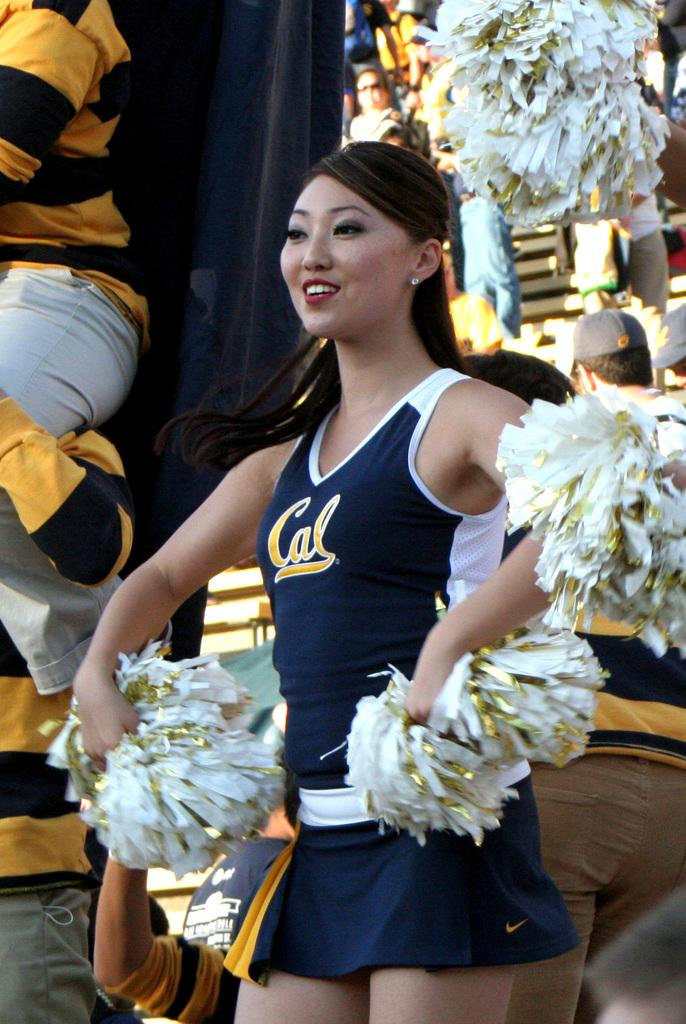<image>
Render a clear and concise summary of the photo. A cheerleader has the word Cal written on her vest. 